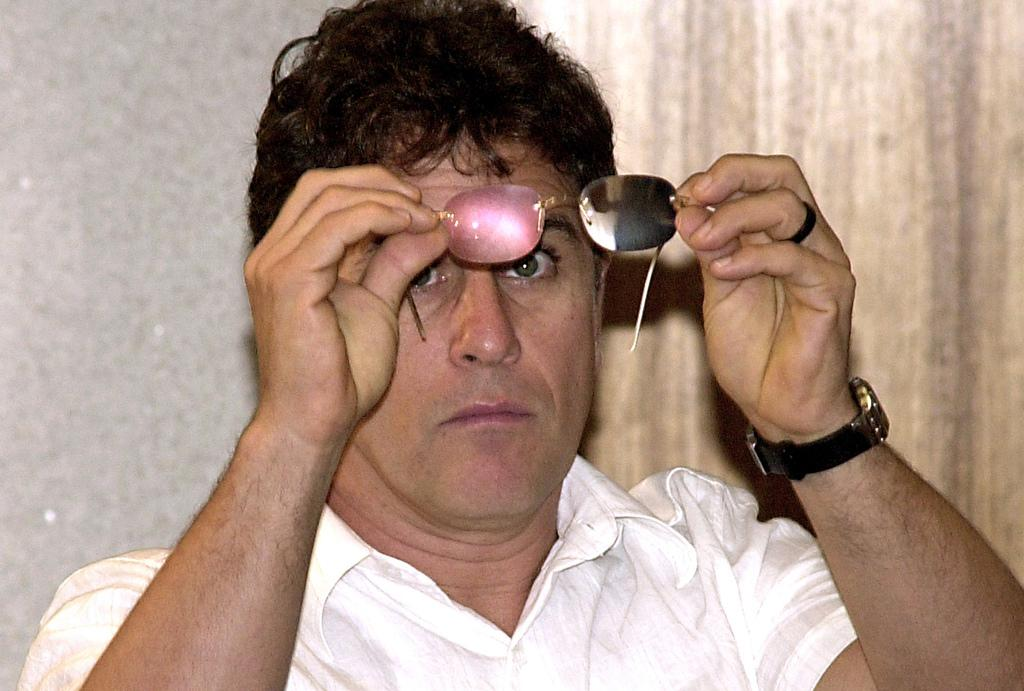Who or what is present in the image? There is a person in the image. What is the person holding in the image? The person is holding spectacles. What can be seen in the background of the image? There is a wall and curtains in the background of the image. What type of quiet team is depicted in the image? There is no team or quiet aspect depicted in the image; it features a person holding spectacles with a wall and curtains in the background. 